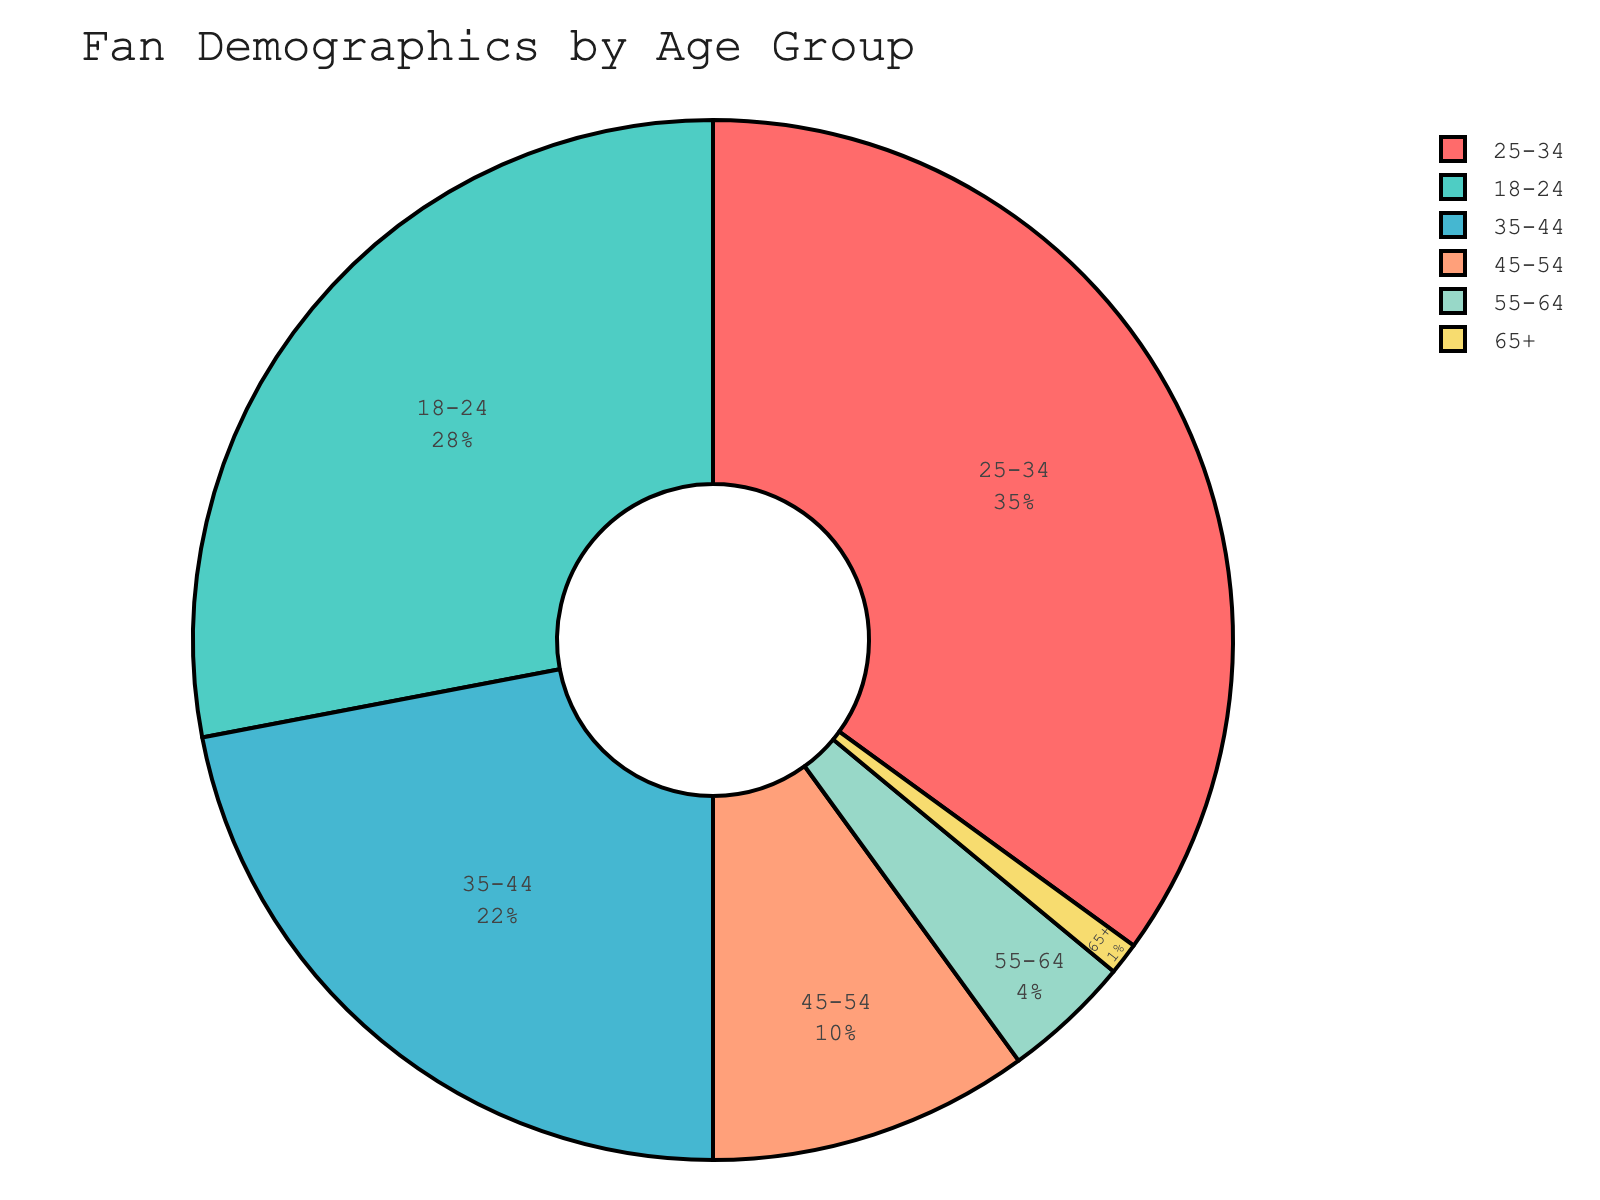Which age group has the highest percentage of fan demographics? The chart segments are labeled with their respective percentages, and the "25-34" age group has the largest segment with 35%.
Answer: 25-34 What is the combined percentage of fans aged 45 and above? To find the combined percentage, sum the percentages of the "45-54", "55-64", and "65+" age groups: 10% + 4% + 1% = 15%.
Answer: 15% Which age group has a larger fan base: 18-24 or 35-44? The pie chart shows that the "18-24" age group has 28%, while the "35-44" age group has 22%. Since 28% is greater than 22%, the 18-24 age group has a larger fan base.
Answer: 18-24 What is the difference in percentage between the age groups 25-34 and 35-44? To find the difference, subtract the percentage of the "35-44" age group from the "25-34" age group: 35% - 22% = 13%.
Answer: 13% Identify the age group with the smallest fan base. By inspecting the pie chart, the smallest segment corresponds to the "65+" age group with 1%.
Answer: 65+ What percentage of fans are younger than 25? The relevant age group is "18-24". The chart shows that this segment accounts for 28% of the total fan base.
Answer: 28% How does the percentage of the 35-44 age group compare to the combined percentage of the 55-64 and 65+ age groups? The "35-44" age group has 22%, while the combined percentage for "55-64" and "65+" is 4% + 1% = 5%. Comparing these, 22% is much greater than 5%.
Answer: 35-44 is greater What proportion of fans are aged between 18 and 44? Sum the percentages of the age groups "18-24", "25-34", and "35-44": 28% + 35% + 22% = 85%.
Answer: 85% Which two age groups together constitute more than half of the fan base? The chart shows that the "18-24" (28%) and "25-34" (35%) age groups together form 28% + 35% = 63%, which is more than half of the fan base.
Answer: 18-24 and 25-34 